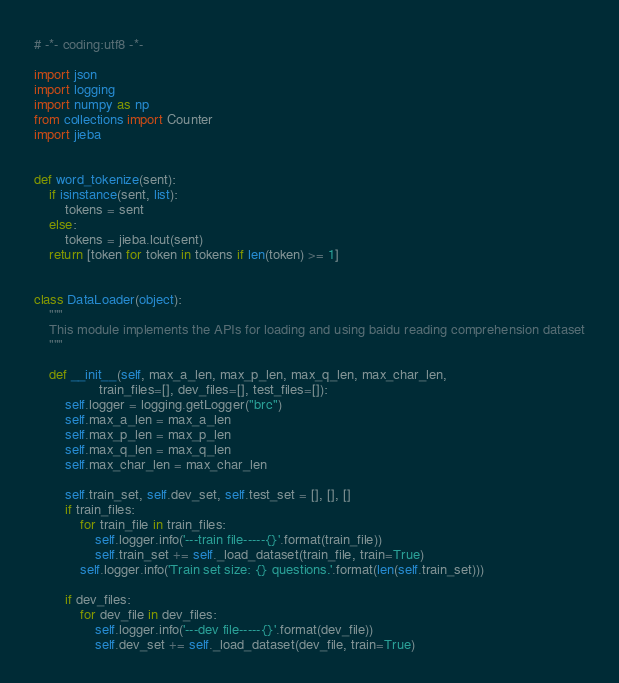Convert code to text. <code><loc_0><loc_0><loc_500><loc_500><_Python_># -*- coding:utf8 -*-

import json
import logging
import numpy as np
from collections import Counter
import jieba


def word_tokenize(sent):
    if isinstance(sent, list):
        tokens = sent
    else:
        tokens = jieba.lcut(sent)
    return [token for token in tokens if len(token) >= 1]


class DataLoader(object):
    """
    This module implements the APIs for loading and using baidu reading comprehension dataset
    """

    def __init__(self, max_a_len, max_p_len, max_q_len, max_char_len,
                 train_files=[], dev_files=[], test_files=[]):
        self.logger = logging.getLogger("brc")
        self.max_a_len = max_a_len
        self.max_p_len = max_p_len
        self.max_q_len = max_q_len
        self.max_char_len = max_char_len

        self.train_set, self.dev_set, self.test_set = [], [], []
        if train_files:
            for train_file in train_files:
                self.logger.info('---train file-----{}'.format(train_file))
                self.train_set += self._load_dataset(train_file, train=True)
            self.logger.info('Train set size: {} questions.'.format(len(self.train_set)))

        if dev_files:
            for dev_file in dev_files:
                self.logger.info('---dev file-----{}'.format(dev_file))
                self.dev_set += self._load_dataset(dev_file, train=True)</code> 